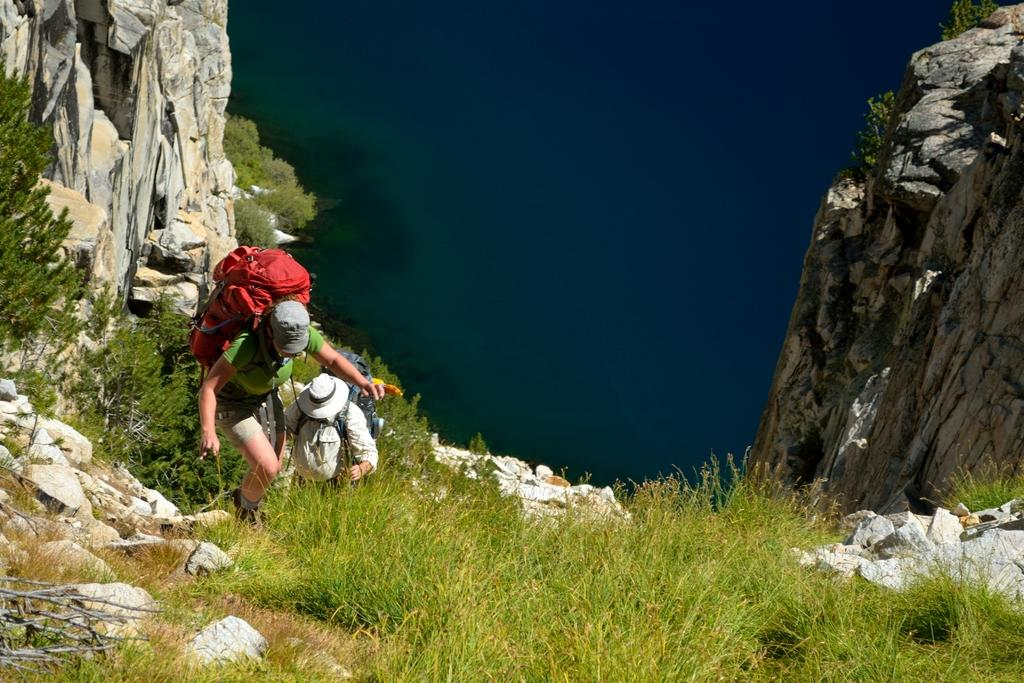How many people are in the image? There are two people in the image. What are the people doing in the image? The people are climbing. What are the people carrying while climbing? The people are wearing heavy bags. What can be seen in the background of the image? The background of the image is water. Where is the sofa located in the image? There is no sofa present in the image. Do the people in the image express regret while climbing? The image does not provide information about the emotions or expressions of the people, so it cannot be determined if they express regret. 